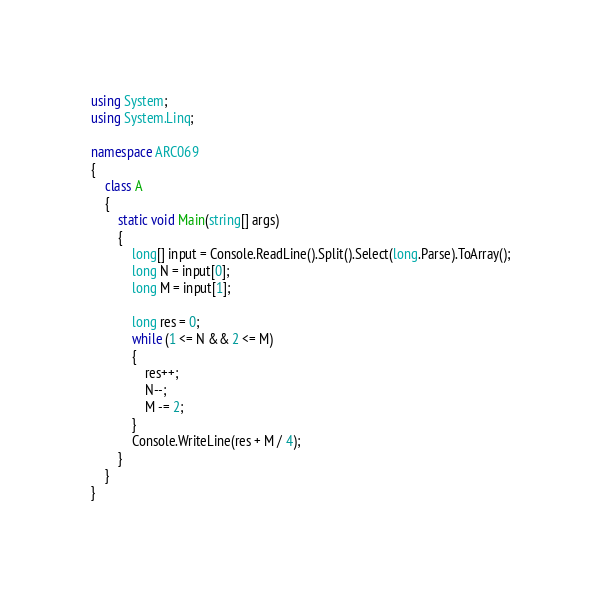Convert code to text. <code><loc_0><loc_0><loc_500><loc_500><_C#_>using System;
using System.Linq;

namespace ARC069
{
    class A
    {
        static void Main(string[] args)
        {
            long[] input = Console.ReadLine().Split().Select(long.Parse).ToArray();
            long N = input[0];
            long M = input[1];

            long res = 0;
            while (1 <= N && 2 <= M)
            {
                res++;
                N--;
                M -= 2;
            }
            Console.WriteLine(res + M / 4);
        }
    }
}
</code> 